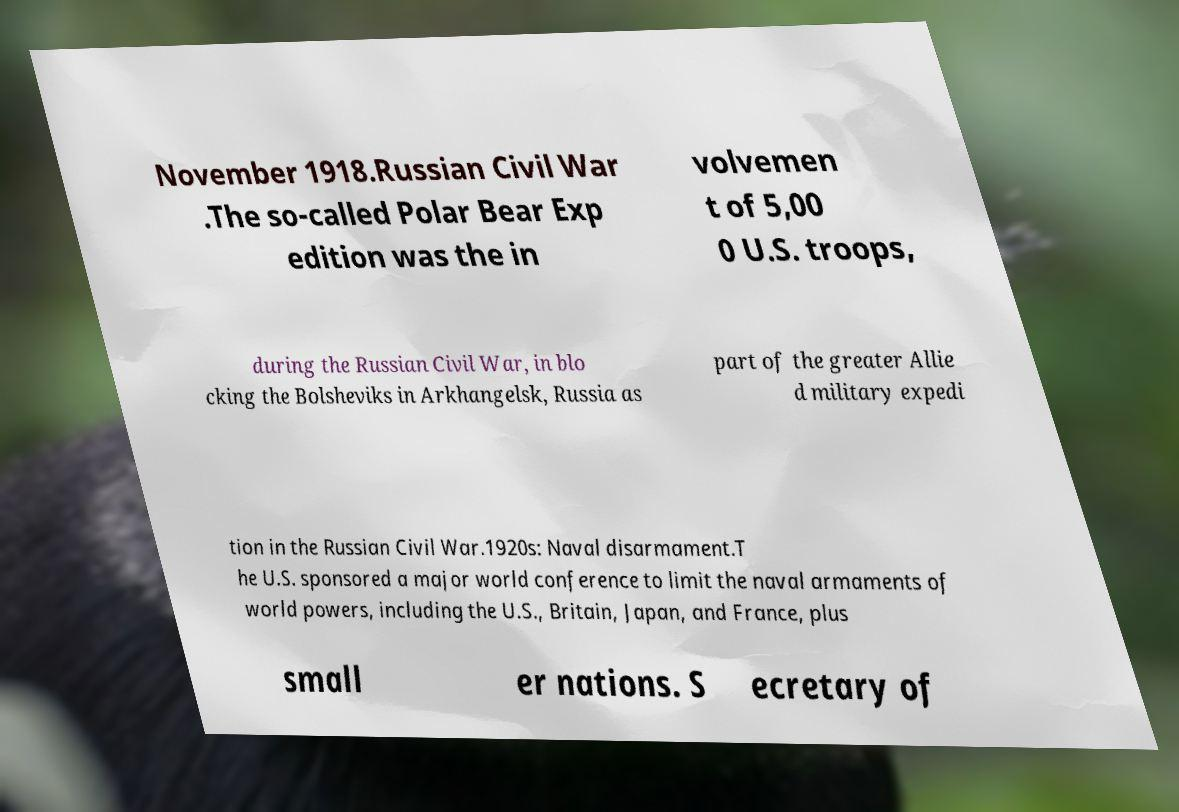Can you accurately transcribe the text from the provided image for me? November 1918.Russian Civil War .The so-called Polar Bear Exp edition was the in volvemen t of 5,00 0 U.S. troops, during the Russian Civil War, in blo cking the Bolsheviks in Arkhangelsk, Russia as part of the greater Allie d military expedi tion in the Russian Civil War.1920s: Naval disarmament.T he U.S. sponsored a major world conference to limit the naval armaments of world powers, including the U.S., Britain, Japan, and France, plus small er nations. S ecretary of 